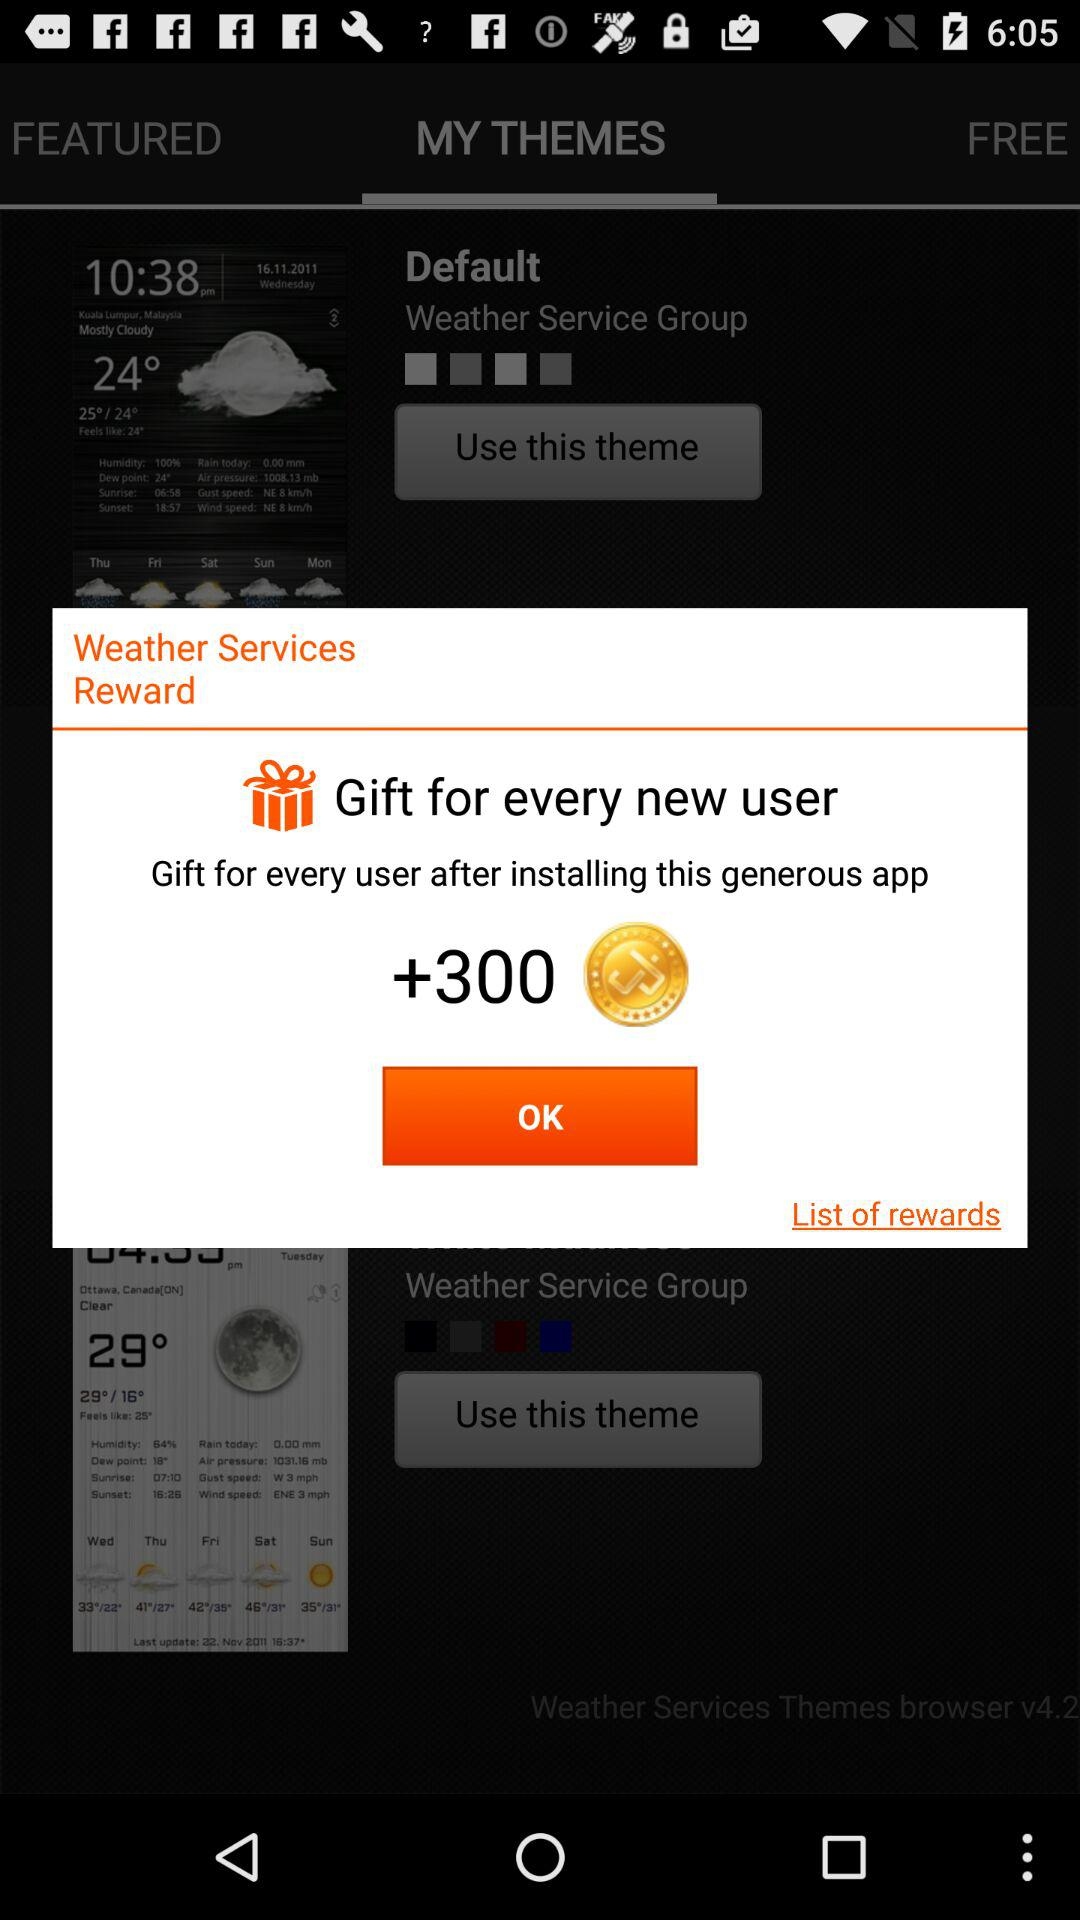How many coins will get to every user after installing this generous application? The number of coins that will get to every user is +300. 